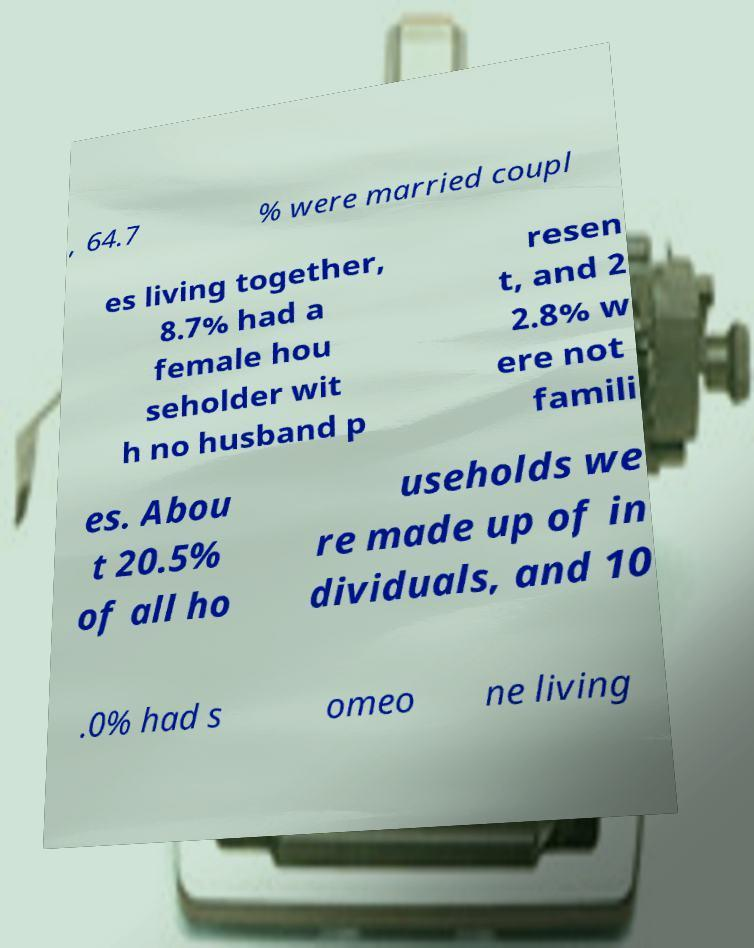Please read and relay the text visible in this image. What does it say? , 64.7 % were married coupl es living together, 8.7% had a female hou seholder wit h no husband p resen t, and 2 2.8% w ere not famili es. Abou t 20.5% of all ho useholds we re made up of in dividuals, and 10 .0% had s omeo ne living 